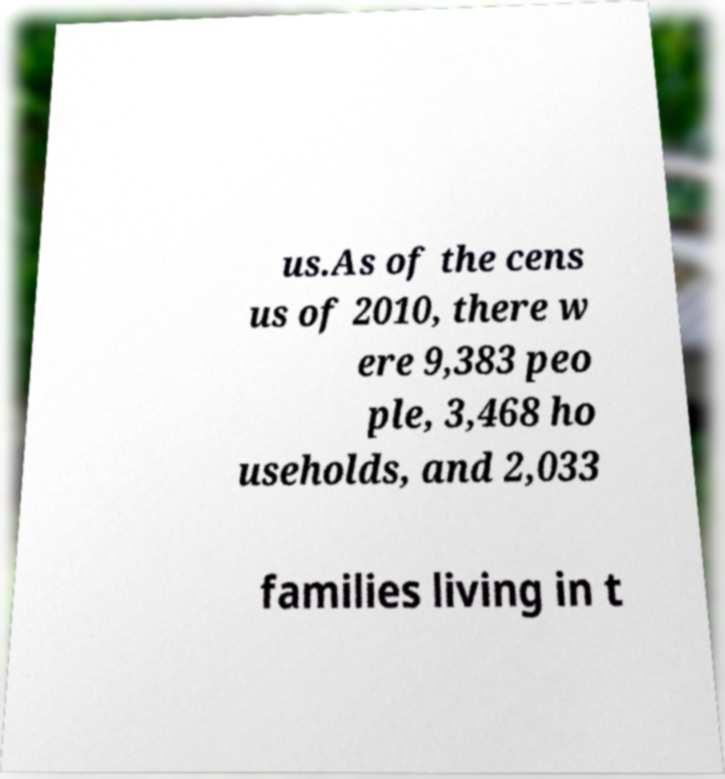Please identify and transcribe the text found in this image. us.As of the cens us of 2010, there w ere 9,383 peo ple, 3,468 ho useholds, and 2,033 families living in t 